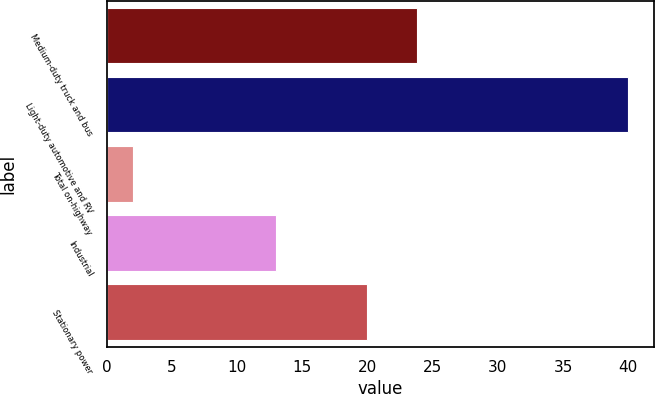Convert chart to OTSL. <chart><loc_0><loc_0><loc_500><loc_500><bar_chart><fcel>Medium-duty truck and bus<fcel>Light-duty automotive and RV<fcel>Total on-highway<fcel>Industrial<fcel>Stationary power<nl><fcel>23.8<fcel>40<fcel>2<fcel>13<fcel>20<nl></chart> 